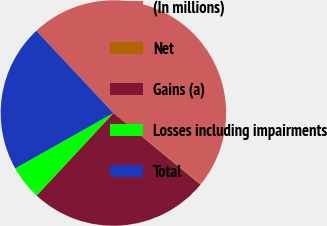<chart> <loc_0><loc_0><loc_500><loc_500><pie_chart><fcel>(In millions)<fcel>Net<fcel>Gains (a)<fcel>Losses including impairments<fcel>Total<nl><fcel>47.82%<fcel>0.12%<fcel>25.97%<fcel>4.89%<fcel>21.2%<nl></chart> 